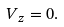<formula> <loc_0><loc_0><loc_500><loc_500>V _ { z } = 0 .</formula> 